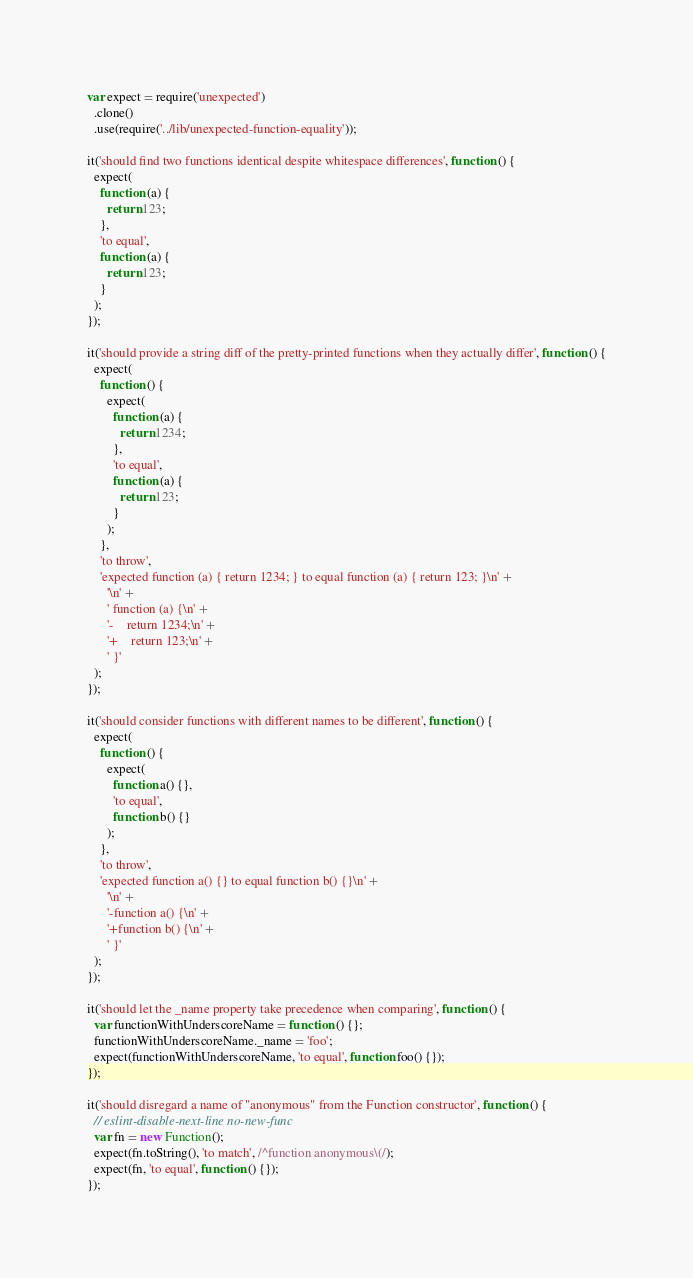Convert code to text. <code><loc_0><loc_0><loc_500><loc_500><_JavaScript_>var expect = require('unexpected')
  .clone()
  .use(require('../lib/unexpected-function-equality'));

it('should find two functions identical despite whitespace differences', function () {
  expect(
    function (a) {
      return 123;
    },
    'to equal',
    function (a) {
      return 123;
    }
  );
});

it('should provide a string diff of the pretty-printed functions when they actually differ', function () {
  expect(
    function () {
      expect(
        function (a) {
          return 1234;
        },
        'to equal',
        function (a) {
          return 123;
        }
      );
    },
    'to throw',
    'expected function (a) { return 1234; } to equal function (a) { return 123; }\n' +
      '\n' +
      ' function (a) {\n' +
      '-    return 1234;\n' +
      '+    return 123;\n' +
      ' }'
  );
});

it('should consider functions with different names to be different', function () {
  expect(
    function () {
      expect(
        function a() {},
        'to equal',
        function b() {}
      );
    },
    'to throw',
    'expected function a() {} to equal function b() {}\n' +
      '\n' +
      '-function a() {\n' +
      '+function b() {\n' +
      ' }'
  );
});

it('should let the _name property take precedence when comparing', function () {
  var functionWithUnderscoreName = function () {};
  functionWithUnderscoreName._name = 'foo';
  expect(functionWithUnderscoreName, 'to equal', function foo() {});
});

it('should disregard a name of "anonymous" from the Function constructor', function () {
  // eslint-disable-next-line no-new-func
  var fn = new Function();
  expect(fn.toString(), 'to match', /^function anonymous\(/);
  expect(fn, 'to equal', function () {});
});
</code> 